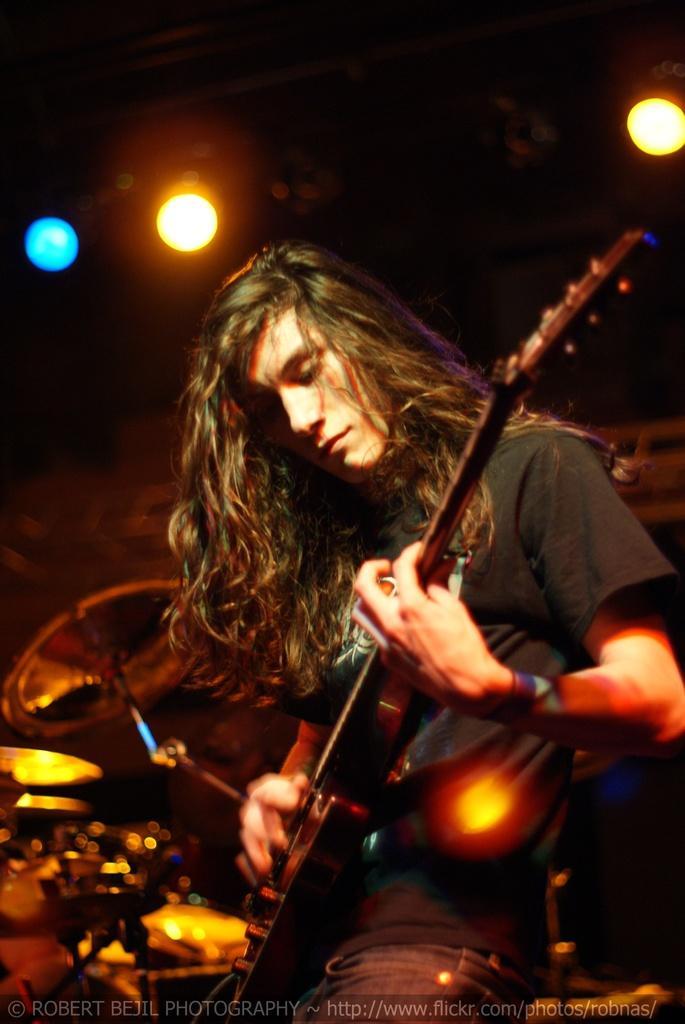Can you describe this image briefly? In this picture there is a man who is wearing black t-shirt and trouser. He is playing a guitar. Behind him I can see the drums. At the top I can see the lights. At the bottom there is a watermark. 